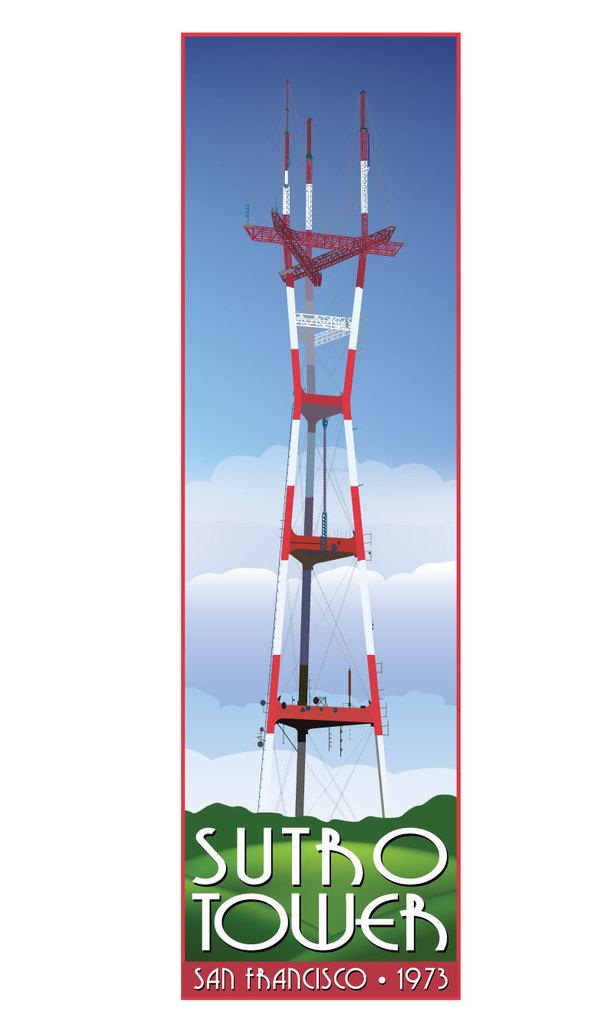What year is shown?
Your answer should be very brief. 1973. 